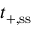<formula> <loc_0><loc_0><loc_500><loc_500>t _ { + , { s s } }</formula> 